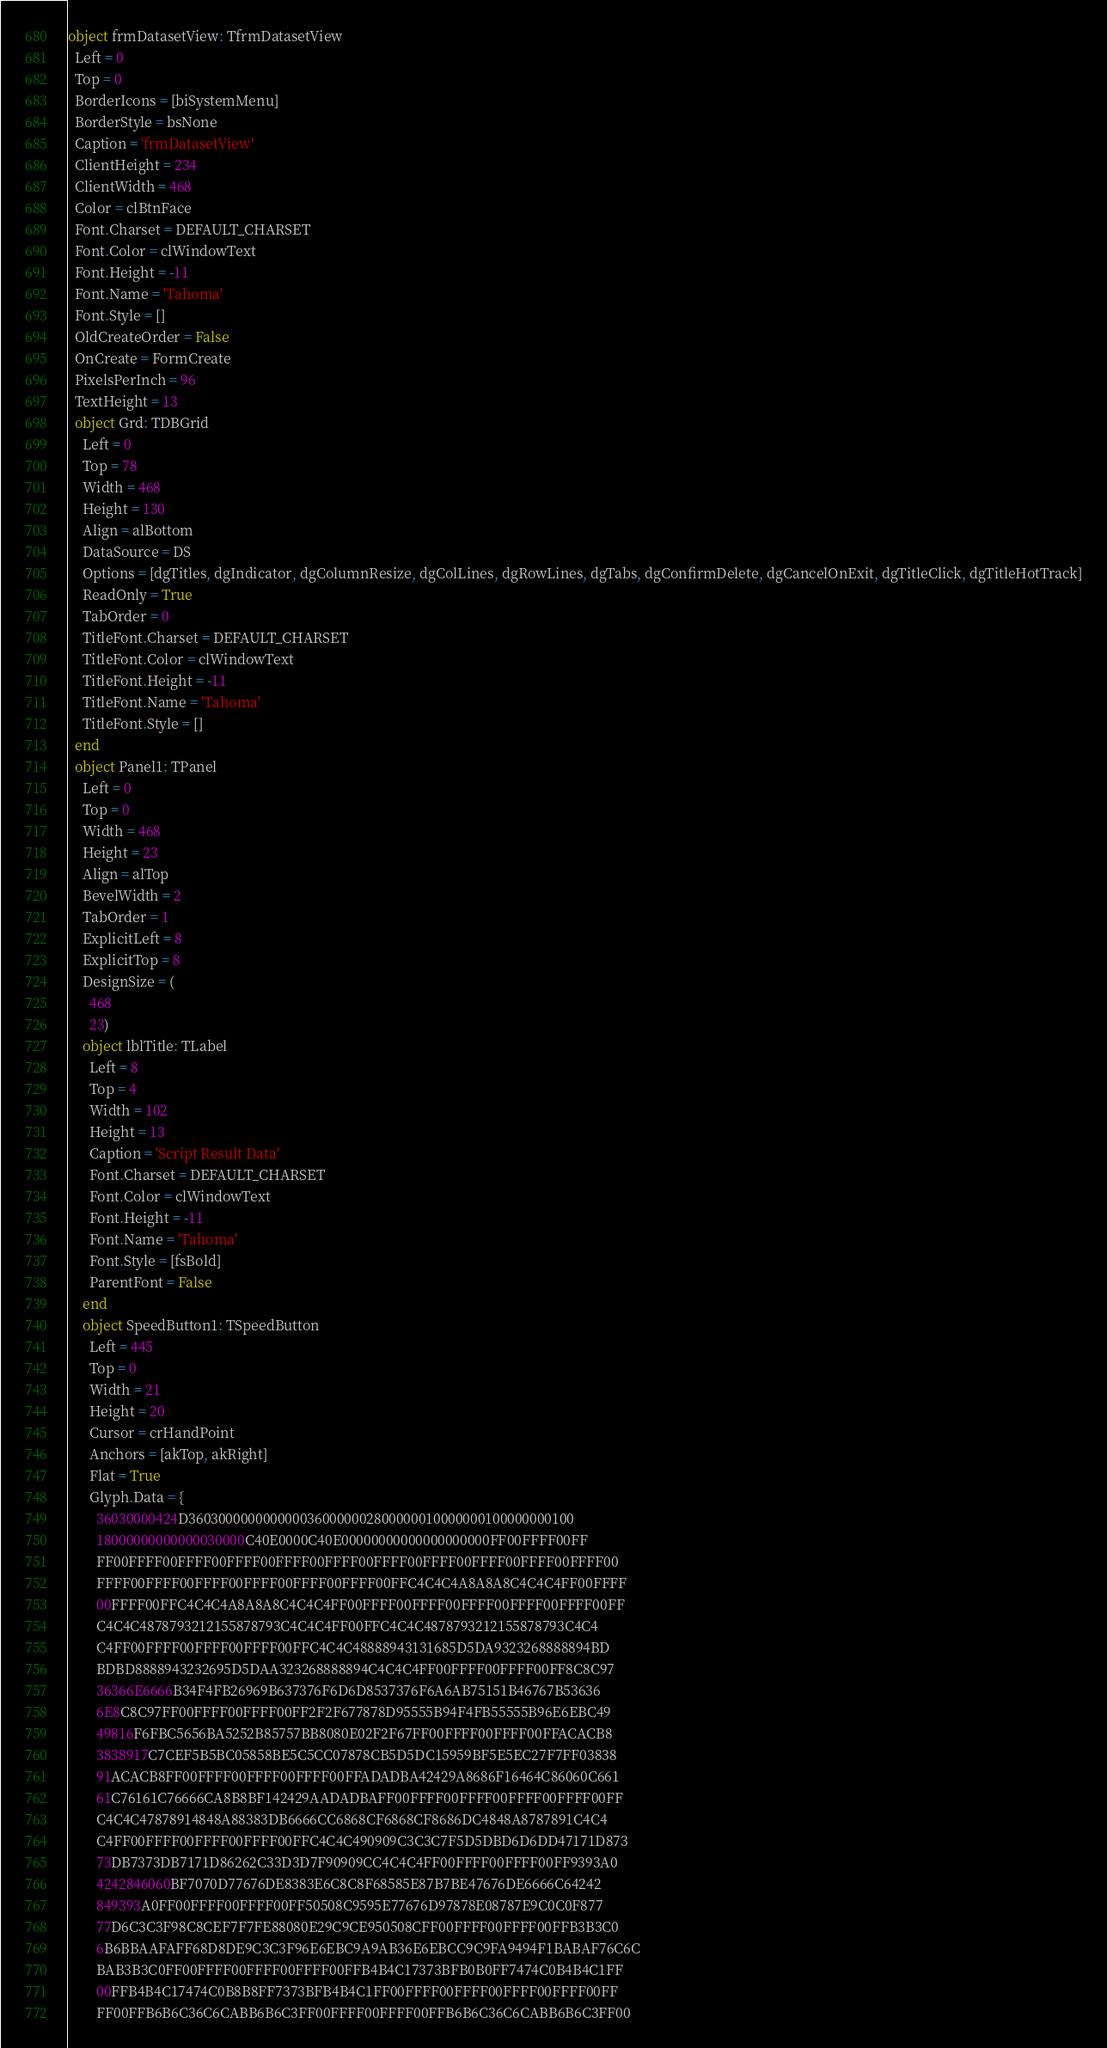Convert code to text. <code><loc_0><loc_0><loc_500><loc_500><_Pascal_>object frmDatasetView: TfrmDatasetView
  Left = 0
  Top = 0
  BorderIcons = [biSystemMenu]
  BorderStyle = bsNone
  Caption = 'frmDatasetView'
  ClientHeight = 234
  ClientWidth = 468
  Color = clBtnFace
  Font.Charset = DEFAULT_CHARSET
  Font.Color = clWindowText
  Font.Height = -11
  Font.Name = 'Tahoma'
  Font.Style = []
  OldCreateOrder = False
  OnCreate = FormCreate
  PixelsPerInch = 96
  TextHeight = 13
  object Grd: TDBGrid
    Left = 0
    Top = 78
    Width = 468
    Height = 130
    Align = alBottom
    DataSource = DS
    Options = [dgTitles, dgIndicator, dgColumnResize, dgColLines, dgRowLines, dgTabs, dgConfirmDelete, dgCancelOnExit, dgTitleClick, dgTitleHotTrack]
    ReadOnly = True
    TabOrder = 0
    TitleFont.Charset = DEFAULT_CHARSET
    TitleFont.Color = clWindowText
    TitleFont.Height = -11
    TitleFont.Name = 'Tahoma'
    TitleFont.Style = []
  end
  object Panel1: TPanel
    Left = 0
    Top = 0
    Width = 468
    Height = 23
    Align = alTop
    BevelWidth = 2
    TabOrder = 1
    ExplicitLeft = 8
    ExplicitTop = 8
    DesignSize = (
      468
      23)
    object lblTitle: TLabel
      Left = 8
      Top = 4
      Width = 102
      Height = 13
      Caption = 'Script Result Data'
      Font.Charset = DEFAULT_CHARSET
      Font.Color = clWindowText
      Font.Height = -11
      Font.Name = 'Tahoma'
      Font.Style = [fsBold]
      ParentFont = False
    end
    object SpeedButton1: TSpeedButton
      Left = 445
      Top = 0
      Width = 21
      Height = 20
      Cursor = crHandPoint
      Anchors = [akTop, akRight]
      Flat = True
      Glyph.Data = {
        36030000424D3603000000000000360000002800000010000000100000000100
        18000000000000030000C40E0000C40E00000000000000000000FF00FFFF00FF
        FF00FFFF00FFFF00FFFF00FFFF00FFFF00FFFF00FFFF00FFFF00FFFF00FFFF00
        FFFF00FFFF00FFFF00FFFF00FFFF00FFFF00FFC4C4C4A8A8A8C4C4C4FF00FFFF
        00FFFF00FFC4C4C4A8A8A8C4C4C4FF00FFFF00FFFF00FFFF00FFFF00FFFF00FF
        C4C4C4878793212155878793C4C4C4FF00FFC4C4C4878793212155878793C4C4
        C4FF00FFFF00FFFF00FFFF00FFC4C4C48888943131685D5DA9323268888894BD
        BDBD8888943232695D5DAA323268888894C4C4C4FF00FFFF00FFFF00FF8C8C97
        36366E6666B34F4FB26969B637376F6D6D8537376F6A6AB75151B46767B53636
        6E8C8C97FF00FFFF00FFFF00FF2F2F677878D95555B94F4FB55555B96E6EBC49
        49816F6FBC5656BA5252B85757BB8080E02F2F67FF00FFFF00FFFF00FFACACB8
        3838917C7CEF5B5BC05858BE5C5CC07878CB5D5DC15959BF5E5EC27F7FF03838
        91ACACB8FF00FFFF00FFFF00FFFF00FFADADBA42429A8686F16464C86060C661
        61C76161C76666CA8B8BF142429AADADBAFF00FFFF00FFFF00FFFF00FFFF00FF
        C4C4C47878914848A88383DB6666CC6868CF6868CF8686DC4848A8787891C4C4
        C4FF00FFFF00FFFF00FFFF00FFC4C4C490909C3C3C7F5D5DBD6D6DD47171D873
        73DB7373DB7171D86262C33D3D7F90909CC4C4C4FF00FFFF00FFFF00FF9393A0
        4242846060BF7070D77676DE8383E6C8C8F68585E87B7BE47676DE6666C64242
        849393A0FF00FFFF00FFFF00FF50508C9595E77676D97878E08787E9C0C0F877
        77D6C3C3F98C8CEF7F7FE88080E29C9CE950508CFF00FFFF00FFFF00FFB3B3C0
        6B6BBAAFAFF68D8DE9C3C3F96E6EBC9A9AB36E6EBCC9C9FA9494F1BABAF76C6C
        BAB3B3C0FF00FFFF00FFFF00FFFF00FFB4B4C17373BFB0B0FF7474C0B4B4C1FF
        00FFB4B4C17474C0B8B8FF7373BFB4B4C1FF00FFFF00FFFF00FFFF00FFFF00FF
        FF00FFB6B6C36C6CABB6B6C3FF00FFFF00FFFF00FFB6B6C36C6CABB6B6C3FF00</code> 